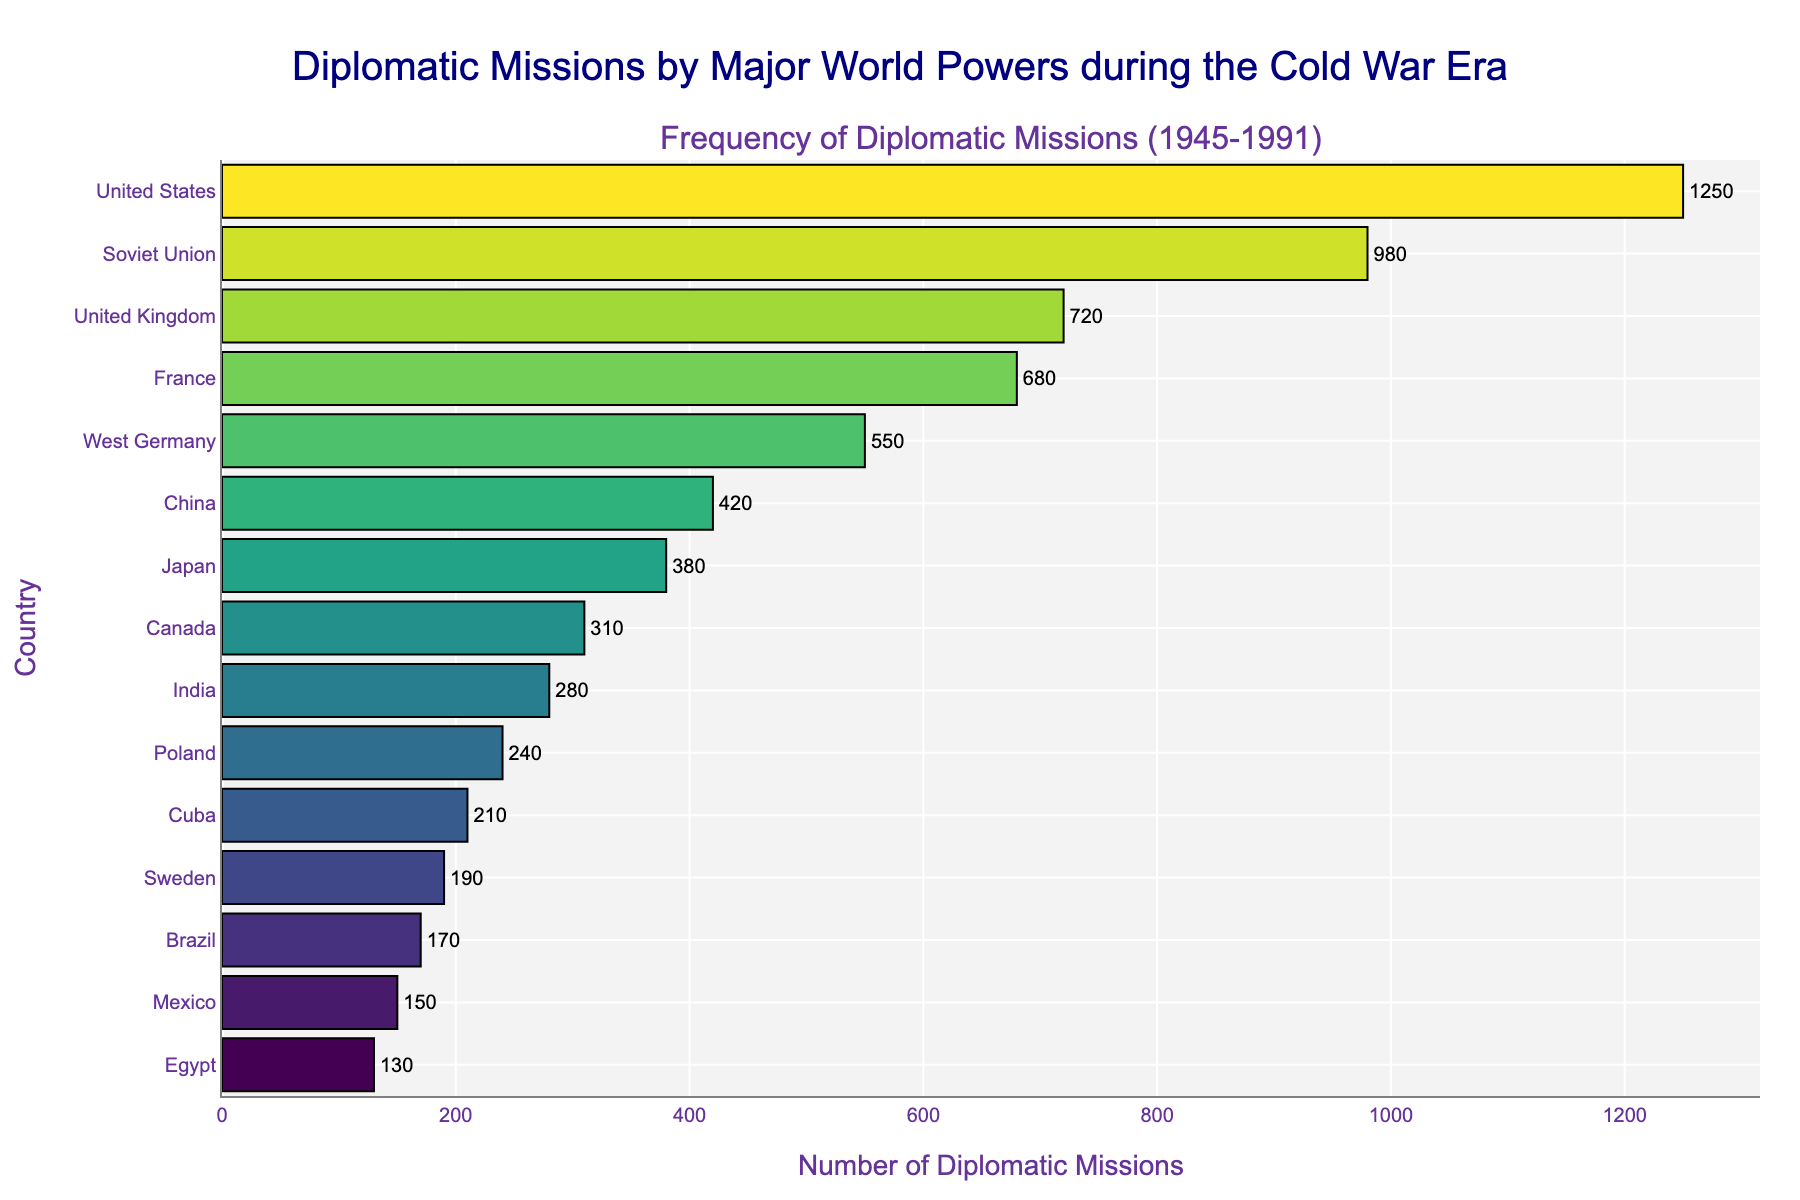Which country had the highest number of diplomatic missions during the Cold War era? By examining the length of the bars, the United States had the longest bar, which indicates it had the highest number of diplomatic missions.
Answer: United States Which country had the second-highest number of diplomatic missions, and how many did they have? The bar next in length after the United States belongs to the Soviet Union, with 980 diplomatic missions.
Answer: Soviet Union, 980 What is the difference in the number of diplomatic missions between the United States and West Germany? The United States had 1250 missions, while West Germany had 550 missions. The difference is 1250 - 550.
Answer: 700 Which three countries had the lowest number of diplomatic missions, and what are their respective counts? The three countries with the shortest bars represent Poland, Cuba, and Egypt, with 240, 210, and 130 missions, respectively.
Answer: Poland: 240, Cuba: 210, Egypt: 130 How many more diplomatic missions did China conduct compared to Japan? China had 420 missions and Japan had 380 missions. The difference is 420 - 380.
Answer: 40 What is the sum of the diplomatic missions conducted by France and Canada? France had 680 missions and Canada had 310. The total is 680 + 310.
Answer: 990 Which country is positioned in the middle when the countries are ranked by the number of diplomatic missions? With 15 countries listed, the middle country (8th in order) is Japan, positioned between China and Canada.
Answer: Japan Which country had a similar number of diplomatic missions as Sweden during this period? Observing the lengths of the bars, Brazil's bar is quite close in length to Sweden's, with Sweden having 190 missions and Brazil having 170.
Answer: Brazil Compare the total number of diplomatic missions of the United Kingdom, France, and West Germany. How does that total compare to the number of missions conducted by the United States? The United Kingdom had 720, France had 680, and West Germany had 550. Their total is 720 + 680 + 550. Comparing this to the United States' 1250 missions indicates they had slightly less combined.
Answer: 1950, less than the United States' 1250 